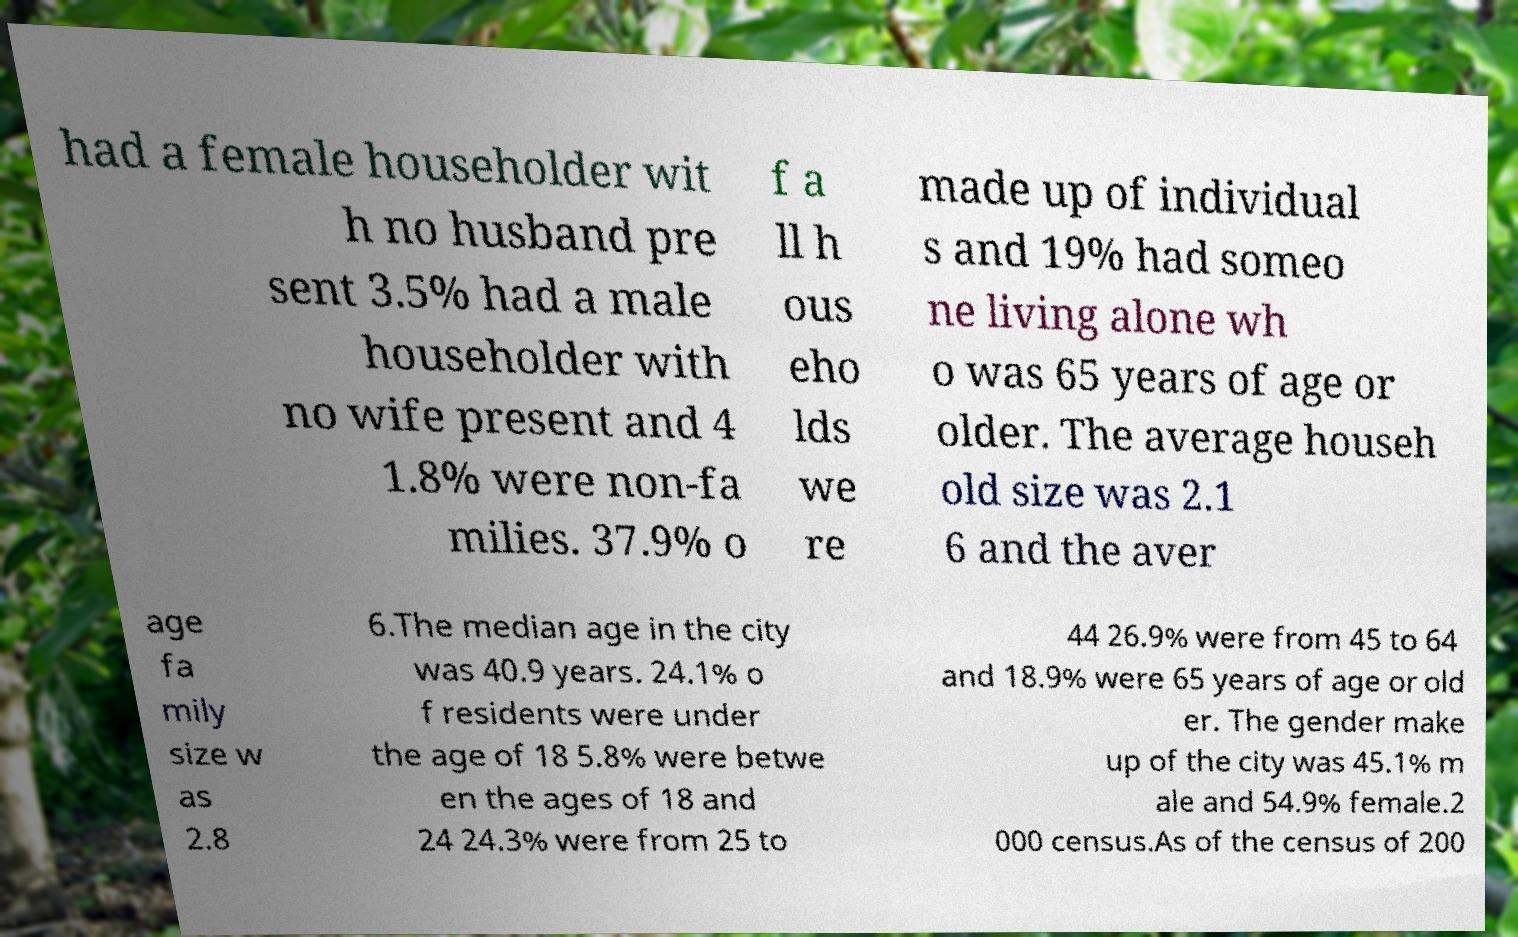I need the written content from this picture converted into text. Can you do that? had a female householder wit h no husband pre sent 3.5% had a male householder with no wife present and 4 1.8% were non-fa milies. 37.9% o f a ll h ous eho lds we re made up of individual s and 19% had someo ne living alone wh o was 65 years of age or older. The average househ old size was 2.1 6 and the aver age fa mily size w as 2.8 6.The median age in the city was 40.9 years. 24.1% o f residents were under the age of 18 5.8% were betwe en the ages of 18 and 24 24.3% were from 25 to 44 26.9% were from 45 to 64 and 18.9% were 65 years of age or old er. The gender make up of the city was 45.1% m ale and 54.9% female.2 000 census.As of the census of 200 